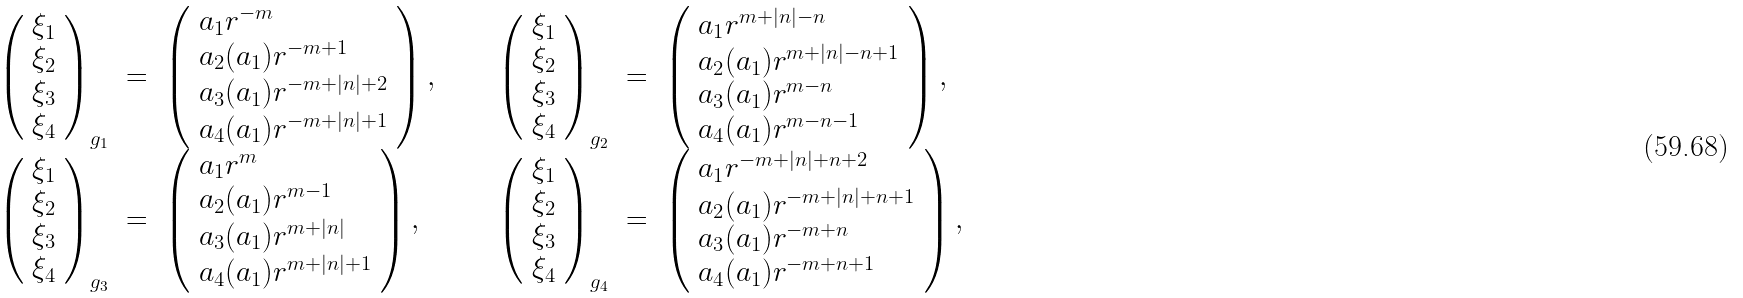Convert formula to latex. <formula><loc_0><loc_0><loc_500><loc_500>\begin{array} { l l l l l l l } { { \left ( \begin{array} { l } { { \xi _ { 1 } } } \\ { { \xi _ { 2 } } } \\ { { \xi _ { 3 } } } \\ { { \xi _ { 4 } } } \end{array} \right ) _ { g _ { 1 } } } } & { = } & { { \left ( \begin{array} { l } { { a _ { 1 } r ^ { - m } } } \\ { { a _ { 2 } ( a _ { 1 } ) r ^ { - m + 1 } } } \\ { { a _ { 3 } ( a _ { 1 } ) r ^ { - m + | n | + 2 } } } \\ { { a _ { 4 } ( a _ { 1 } ) r ^ { - m + | n | + 1 } } } \end{array} \right ) , } } & { \quad } & { { \left ( \begin{array} { l } { { \xi _ { 1 } } } \\ { { \xi _ { 2 } } } \\ { { \xi _ { 3 } } } \\ { { \xi _ { 4 } } } \end{array} \right ) _ { g _ { 2 } } } } & { = } & { { \left ( \begin{array} { l } { { a _ { 1 } r ^ { m + | n | - n } } } \\ { { a _ { 2 } ( a _ { 1 } ) r ^ { m + | n | - n + 1 } } } \\ { { a _ { 3 } ( a _ { 1 } ) r ^ { m - n } } } \\ { { a _ { 4 } ( a _ { 1 } ) r ^ { m - n - 1 } } } \end{array} \right ) , } } \\ { { \left ( \begin{array} { l } { { \xi _ { 1 } } } \\ { { \xi _ { 2 } } } \\ { { \xi _ { 3 } } } \\ { { \xi _ { 4 } } } \end{array} \right ) _ { g _ { 3 } } } } & { = } & { { \left ( \begin{array} { l } { { a _ { 1 } r ^ { m } } } \\ { { a _ { 2 } ( a _ { 1 } ) r ^ { m - 1 } } } \\ { { a _ { 3 } ( a _ { 1 } ) r ^ { m + | n | } } } \\ { { a _ { 4 } ( a _ { 1 } ) r ^ { m + | n | + 1 } } } \end{array} \right ) , } } & { \quad } & { { \left ( \begin{array} { l } { { \xi _ { 1 } } } \\ { { \xi _ { 2 } } } \\ { { \xi _ { 3 } } } \\ { { \xi _ { 4 } } } \end{array} \right ) _ { g _ { 4 } } } } & { = } & { { \left ( \begin{array} { l } { { a _ { 1 } r ^ { - m + | n | + n + 2 } } } \\ { { a _ { 2 } ( a _ { 1 } ) r ^ { - m + | n | + n + 1 } } } \\ { { a _ { 3 } ( a _ { 1 } ) r ^ { - m + n } } } \\ { { a _ { 4 } ( a _ { 1 } ) r ^ { - m + n + 1 } } } \end{array} \right ) , } } \end{array}</formula> 